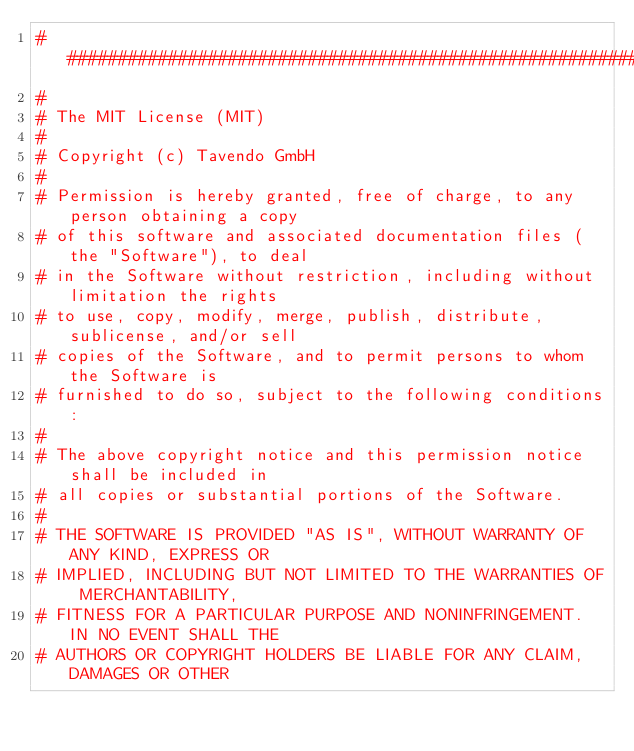Convert code to text. <code><loc_0><loc_0><loc_500><loc_500><_Python_>###############################################################################
#
# The MIT License (MIT)
#
# Copyright (c) Tavendo GmbH
#
# Permission is hereby granted, free of charge, to any person obtaining a copy
# of this software and associated documentation files (the "Software"), to deal
# in the Software without restriction, including without limitation the rights
# to use, copy, modify, merge, publish, distribute, sublicense, and/or sell
# copies of the Software, and to permit persons to whom the Software is
# furnished to do so, subject to the following conditions:
#
# The above copyright notice and this permission notice shall be included in
# all copies or substantial portions of the Software.
#
# THE SOFTWARE IS PROVIDED "AS IS", WITHOUT WARRANTY OF ANY KIND, EXPRESS OR
# IMPLIED, INCLUDING BUT NOT LIMITED TO THE WARRANTIES OF MERCHANTABILITY,
# FITNESS FOR A PARTICULAR PURPOSE AND NONINFRINGEMENT. IN NO EVENT SHALL THE
# AUTHORS OR COPYRIGHT HOLDERS BE LIABLE FOR ANY CLAIM, DAMAGES OR OTHER</code> 